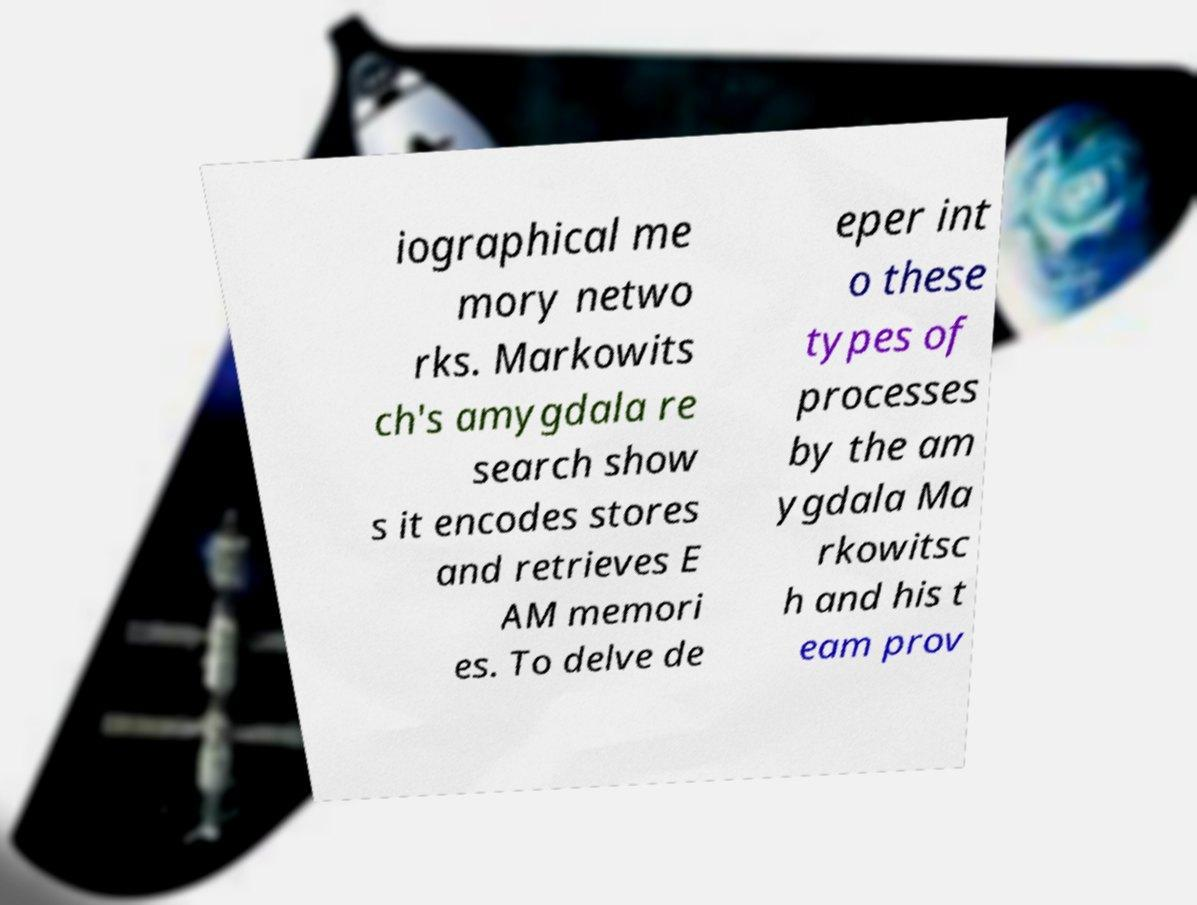Please read and relay the text visible in this image. What does it say? iographical me mory netwo rks. Markowits ch's amygdala re search show s it encodes stores and retrieves E AM memori es. To delve de eper int o these types of processes by the am ygdala Ma rkowitsc h and his t eam prov 